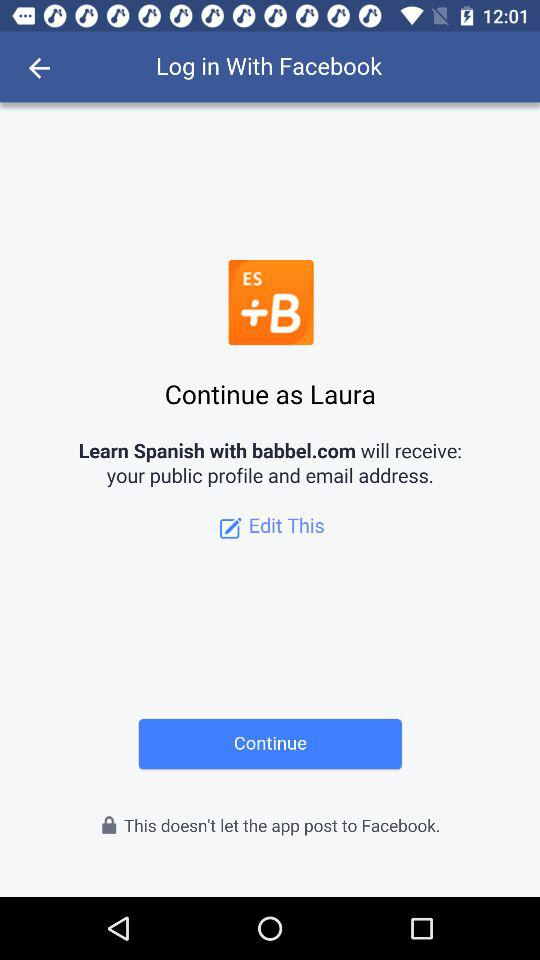What application is asking for permission? The application asking for permission is "Learn Spanish with babbel.com". 